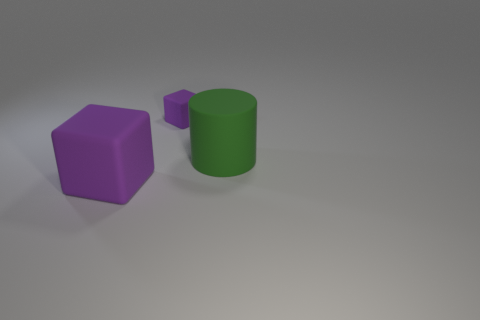What number of small things are either yellow matte cylinders or matte blocks?
Your response must be concise. 1. Is there anything else of the same color as the tiny cube?
Offer a very short reply. Yes. There is a purple rubber cube behind the rubber cylinder; is it the same size as the big rubber cylinder?
Provide a short and direct response. No. The big rubber object right of the block to the left of the purple matte thing that is right of the big rubber cube is what color?
Give a very brief answer. Green. The large matte block has what color?
Offer a terse response. Purple. Is the color of the large rubber cylinder the same as the tiny matte thing?
Give a very brief answer. No. Is the material of the object on the left side of the tiny matte block the same as the purple object behind the green cylinder?
Your response must be concise. Yes. What material is the large purple thing that is the same shape as the small purple object?
Give a very brief answer. Rubber. Are the green cylinder and the large cube made of the same material?
Your answer should be very brief. Yes. What color is the block in front of the purple block on the right side of the big purple cube?
Ensure brevity in your answer.  Purple. 